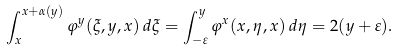Convert formula to latex. <formula><loc_0><loc_0><loc_500><loc_500>\int _ { x } ^ { x + \alpha ( y ) } \varphi ^ { y } ( \xi , y , x ) \, d \xi = \int _ { - \varepsilon } ^ { y } \varphi ^ { x } ( x , \eta , x ) \, d \eta = 2 ( y + \varepsilon ) .</formula> 